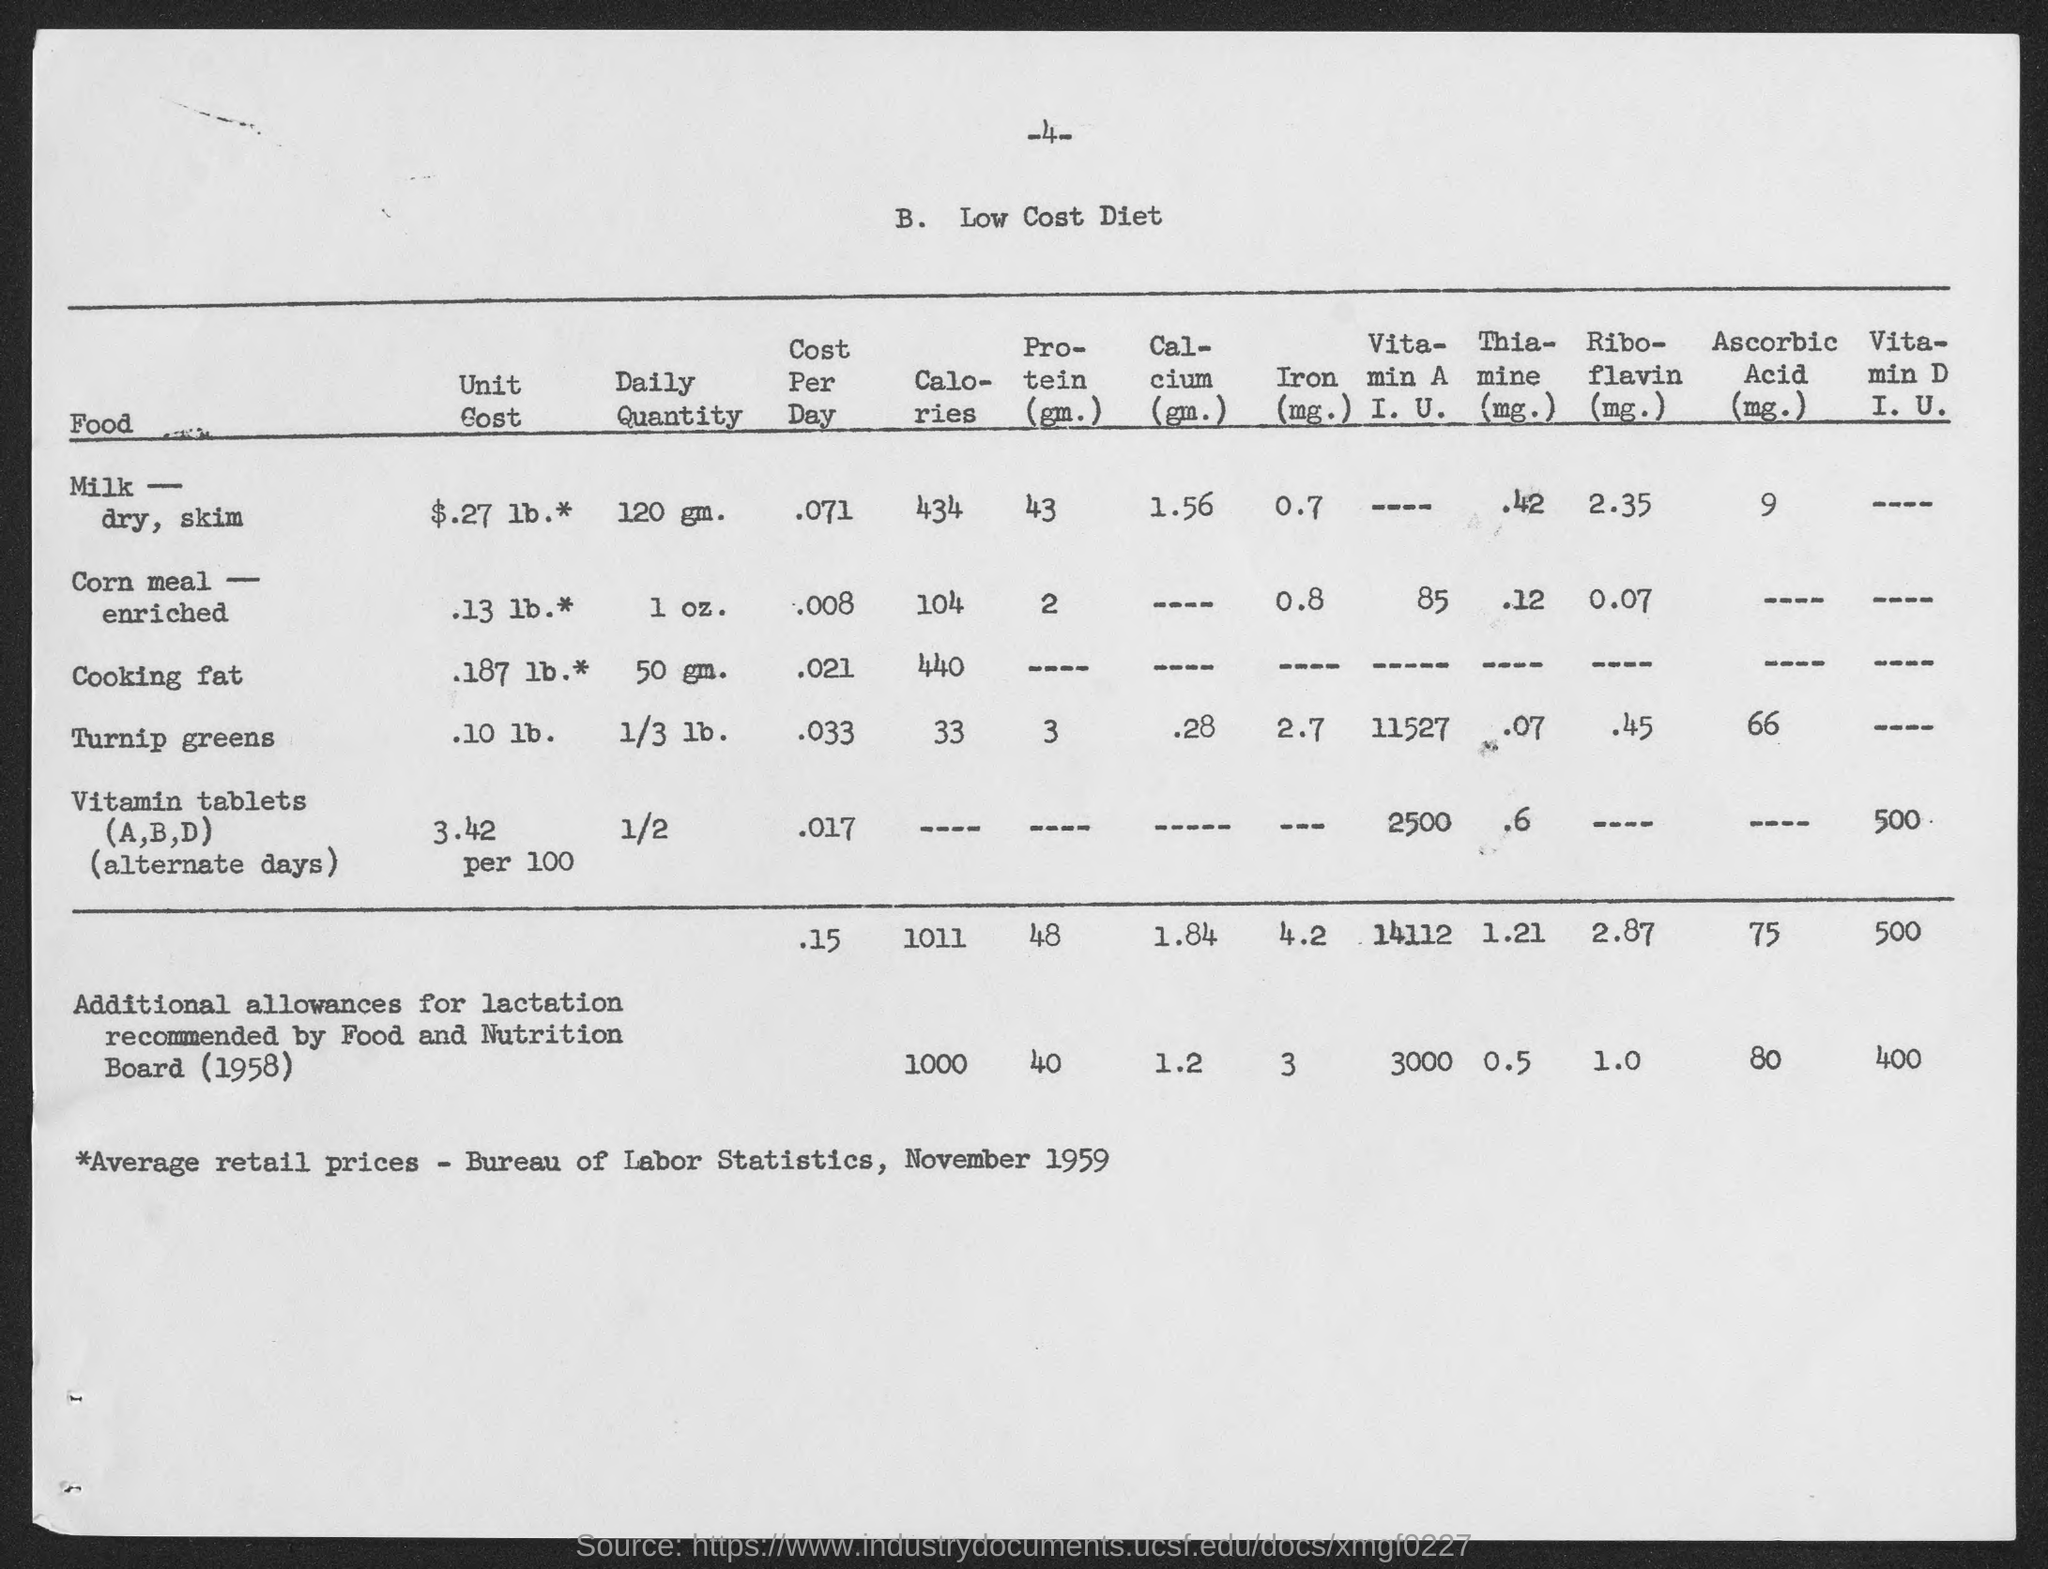What is the Daily Quantity for Milk-dry, skin?
Make the answer very short. 120 gm. What is the Daily Quantity for Corn meal-enriched?
Keep it short and to the point. 1 oz. What is the Daily Quantity for Cooking Fat?
Your answer should be very brief. 50 gm. What is the Daily Quantity for Turnip Greens?
Your answer should be compact. 1/3 lb. What is the Daily Quantity for Vitamin Tablets?
Ensure brevity in your answer.  1/2. What is the Cost per day for Milk-dry, skin?
Provide a short and direct response. .071. What is the Cost per day for Corn meal-enriched?
Provide a short and direct response. .008. What is the Cost per day for Cooking Fat?
Provide a succinct answer. .021. What is the Cost per day for Turnip Greens?
Give a very brief answer. .033. What is the Cost per day for Vitamin Tablets?
Your answer should be very brief. .017. 